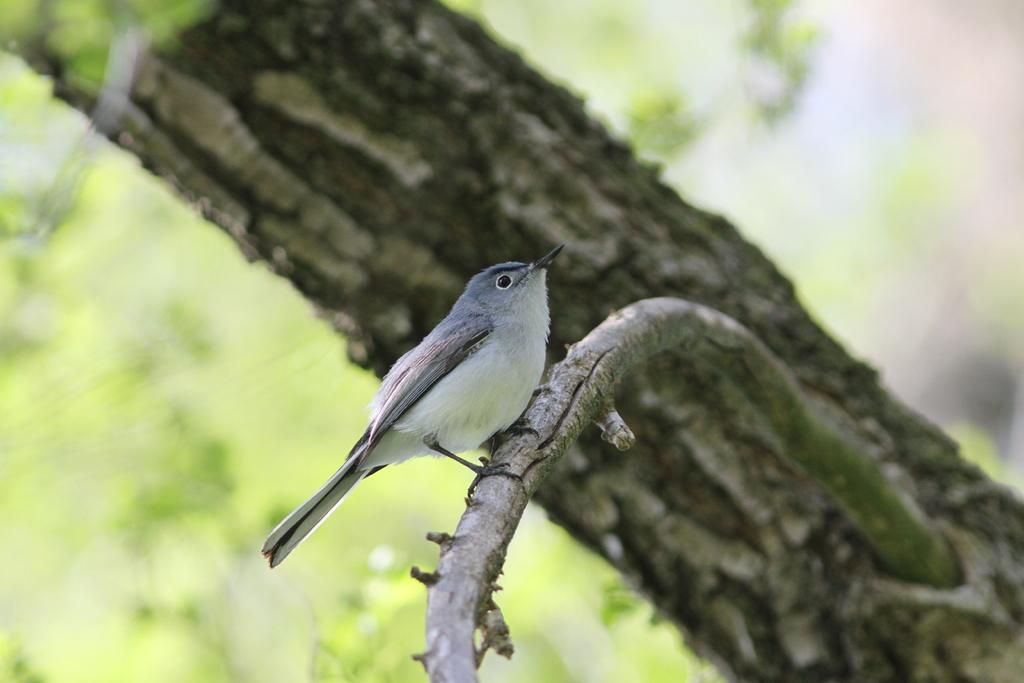Please provide a concise description of this image. In this image we can see a bird on the branch of a tree. In the background we can see tree trunk and the image is blur but we can see objects. 